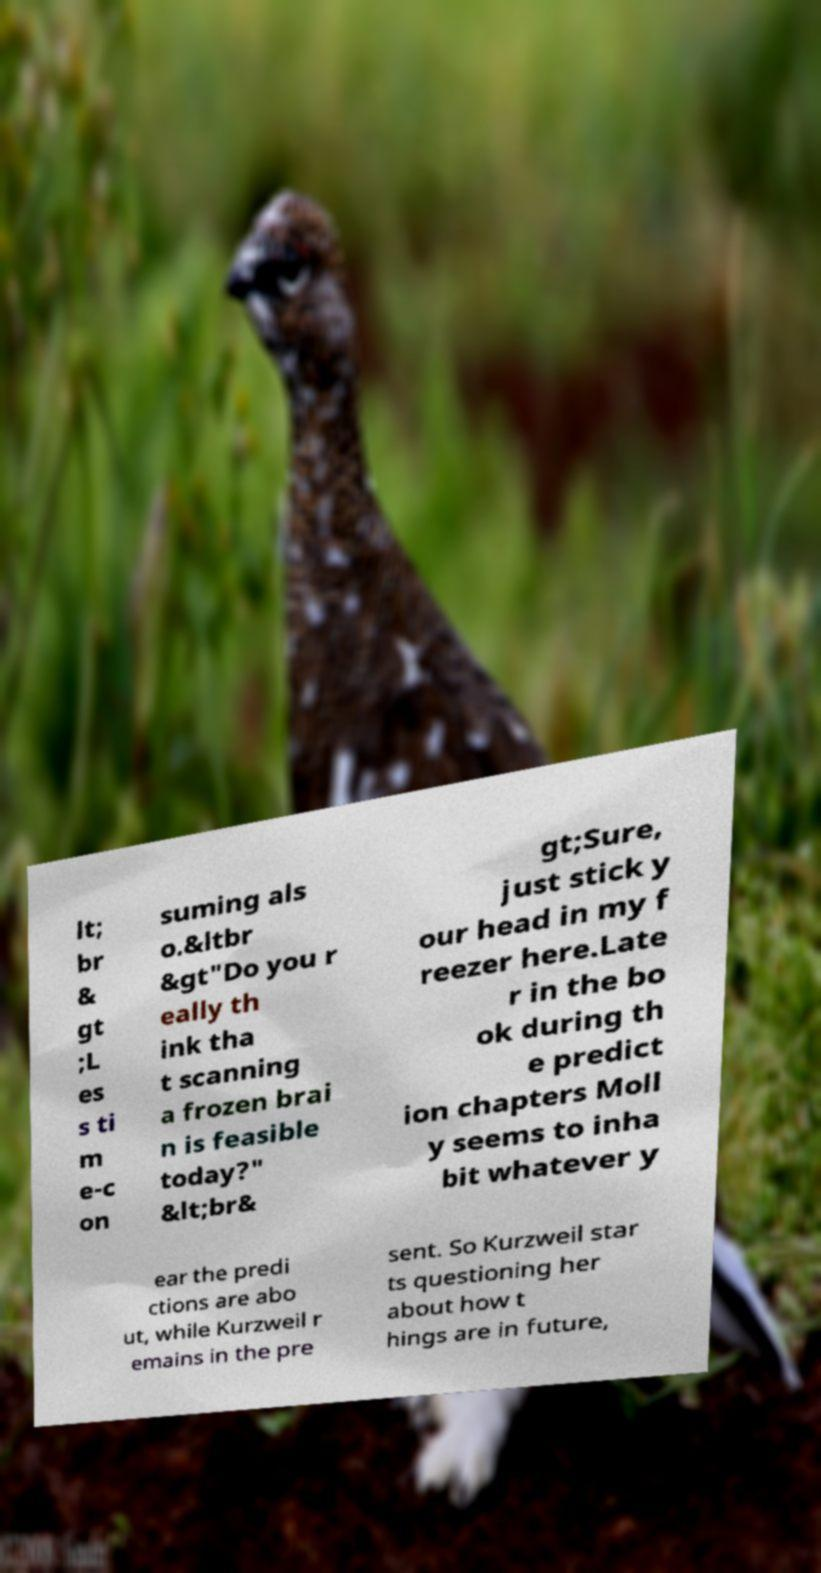There's text embedded in this image that I need extracted. Can you transcribe it verbatim? lt; br & gt ;L es s ti m e-c on suming als o.&ltbr &gt"Do you r eally th ink tha t scanning a frozen brai n is feasible today?" &lt;br& gt;Sure, just stick y our head in my f reezer here.Late r in the bo ok during th e predict ion chapters Moll y seems to inha bit whatever y ear the predi ctions are abo ut, while Kurzweil r emains in the pre sent. So Kurzweil star ts questioning her about how t hings are in future, 